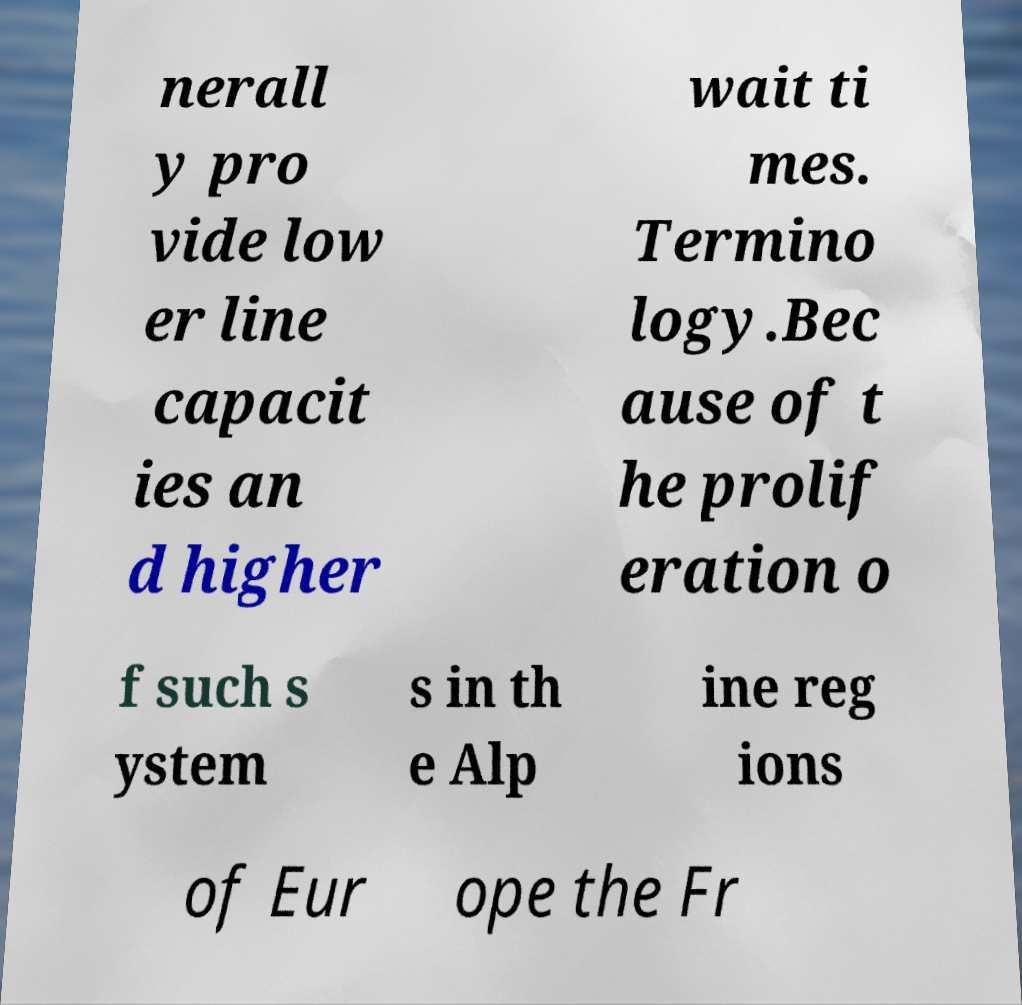Please read and relay the text visible in this image. What does it say? nerall y pro vide low er line capacit ies an d higher wait ti mes. Termino logy.Bec ause of t he prolif eration o f such s ystem s in th e Alp ine reg ions of Eur ope the Fr 